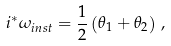Convert formula to latex. <formula><loc_0><loc_0><loc_500><loc_500>i ^ { * } \omega _ { i n s t } = \frac { 1 } { 2 } \left ( \theta _ { 1 } + \theta _ { 2 } \right ) \, ,</formula> 